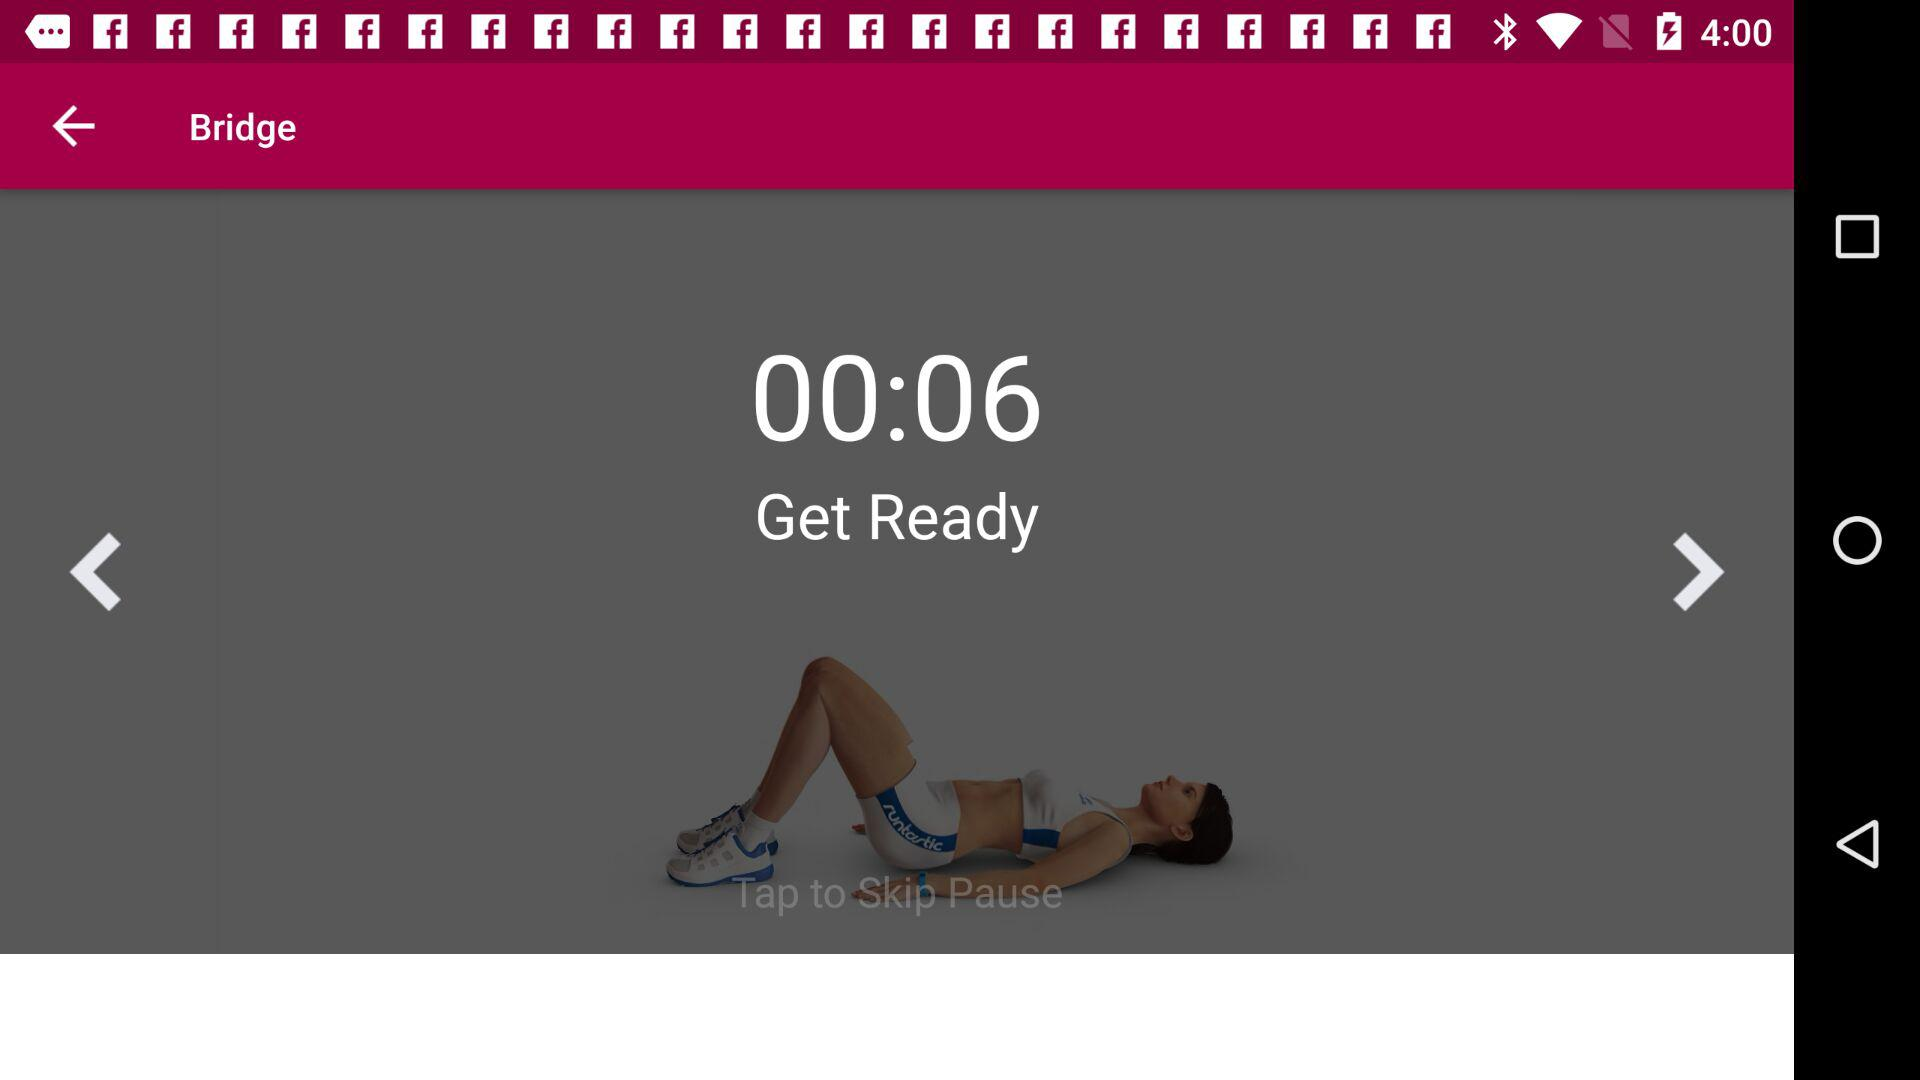How many exercises are there? There are 32 exercises. 